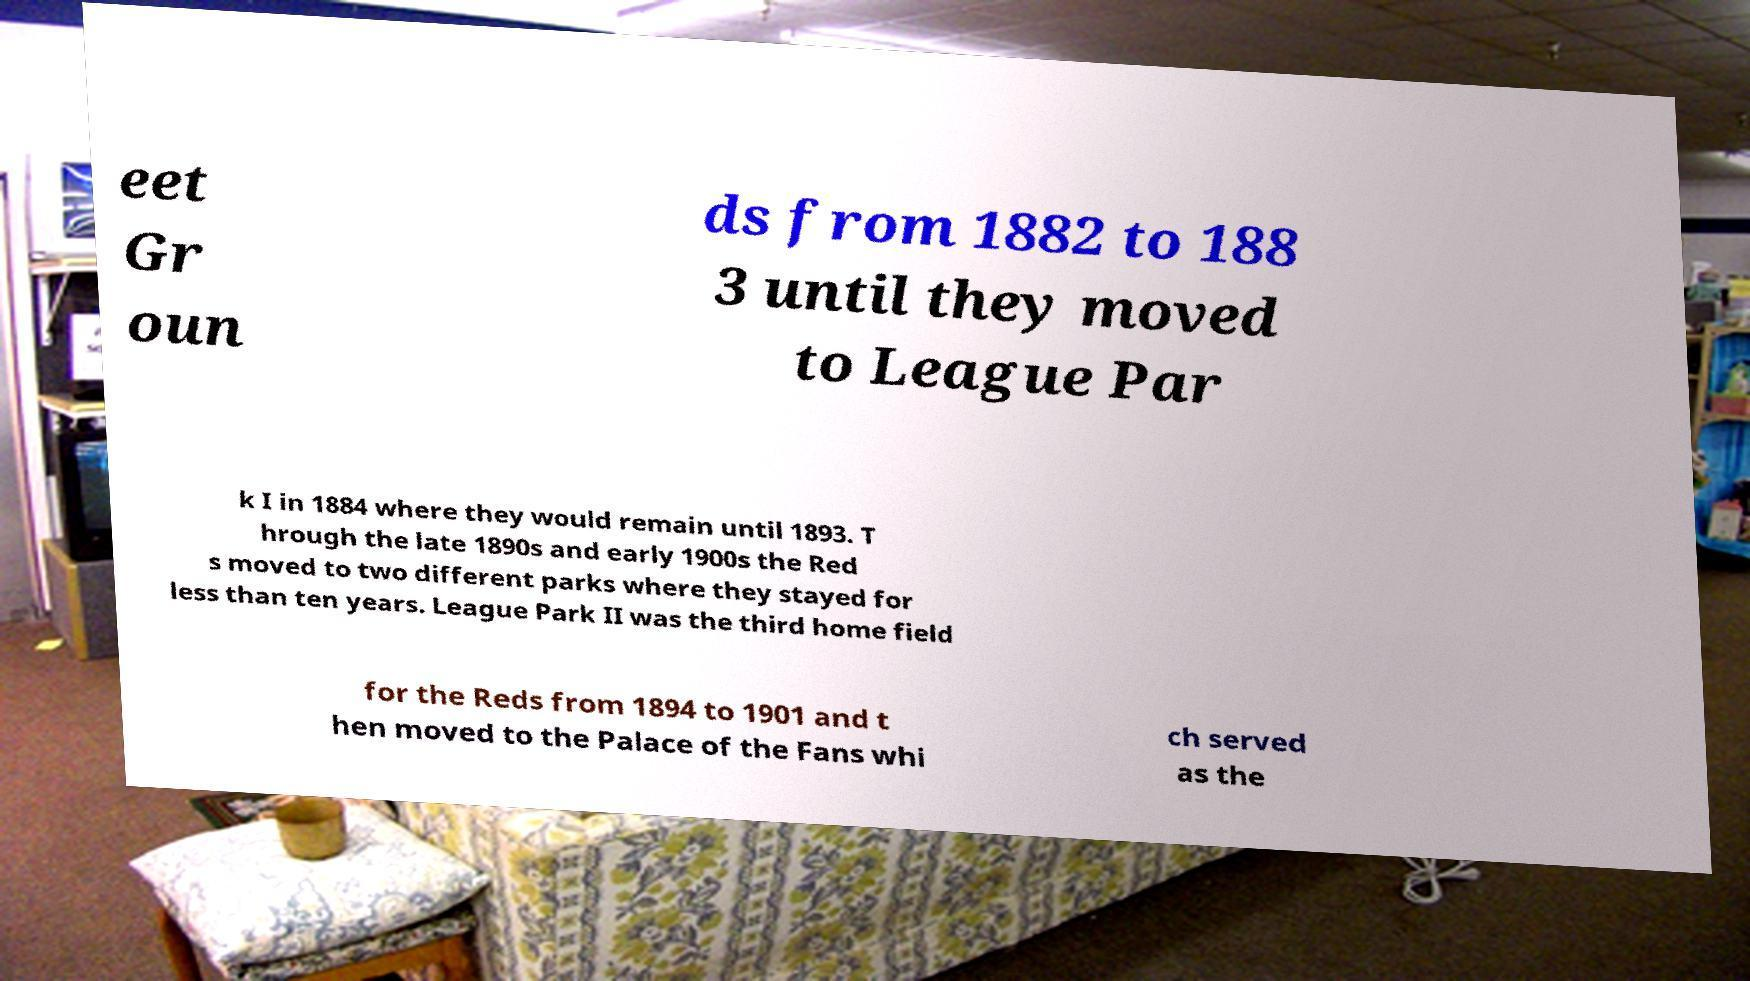Could you extract and type out the text from this image? eet Gr oun ds from 1882 to 188 3 until they moved to League Par k I in 1884 where they would remain until 1893. T hrough the late 1890s and early 1900s the Red s moved to two different parks where they stayed for less than ten years. League Park II was the third home field for the Reds from 1894 to 1901 and t hen moved to the Palace of the Fans whi ch served as the 